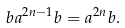<formula> <loc_0><loc_0><loc_500><loc_500>b a ^ { 2 n - 1 } b = a ^ { 2 n } b .</formula> 